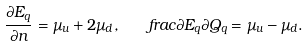Convert formula to latex. <formula><loc_0><loc_0><loc_500><loc_500>\frac { \partial E _ { q } } { \partial n } = \mu _ { u } + 2 \mu _ { d } , \quad f r a c { \partial E _ { q } } { \partial Q _ { q } } = \mu _ { u } - \mu _ { d } .</formula> 